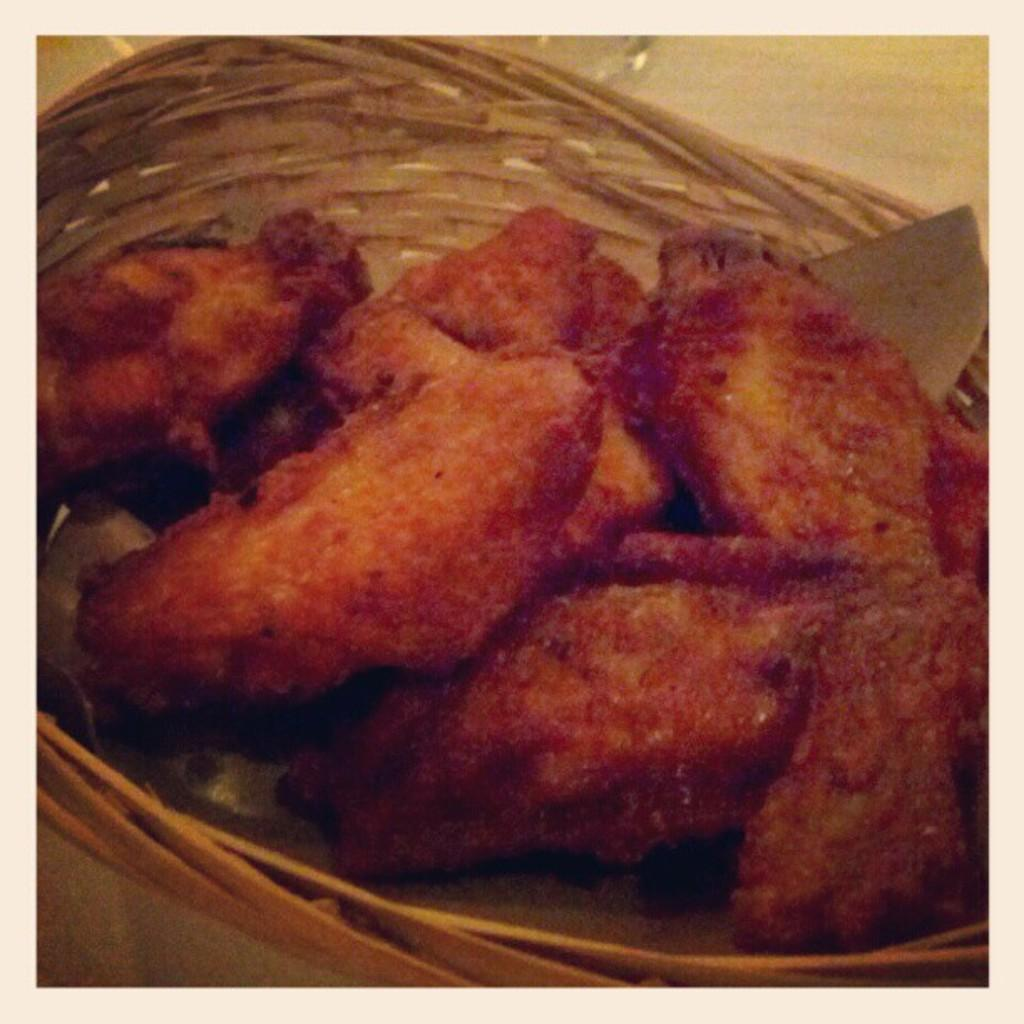What is contained within the basket in the image? There is food in a basket. Where is the basket located in the image? The basket is placed on a surface. How many cows are present in the image? There are no cows present in the image. What type of suit is visible in the image? There is no suit present in the image. 